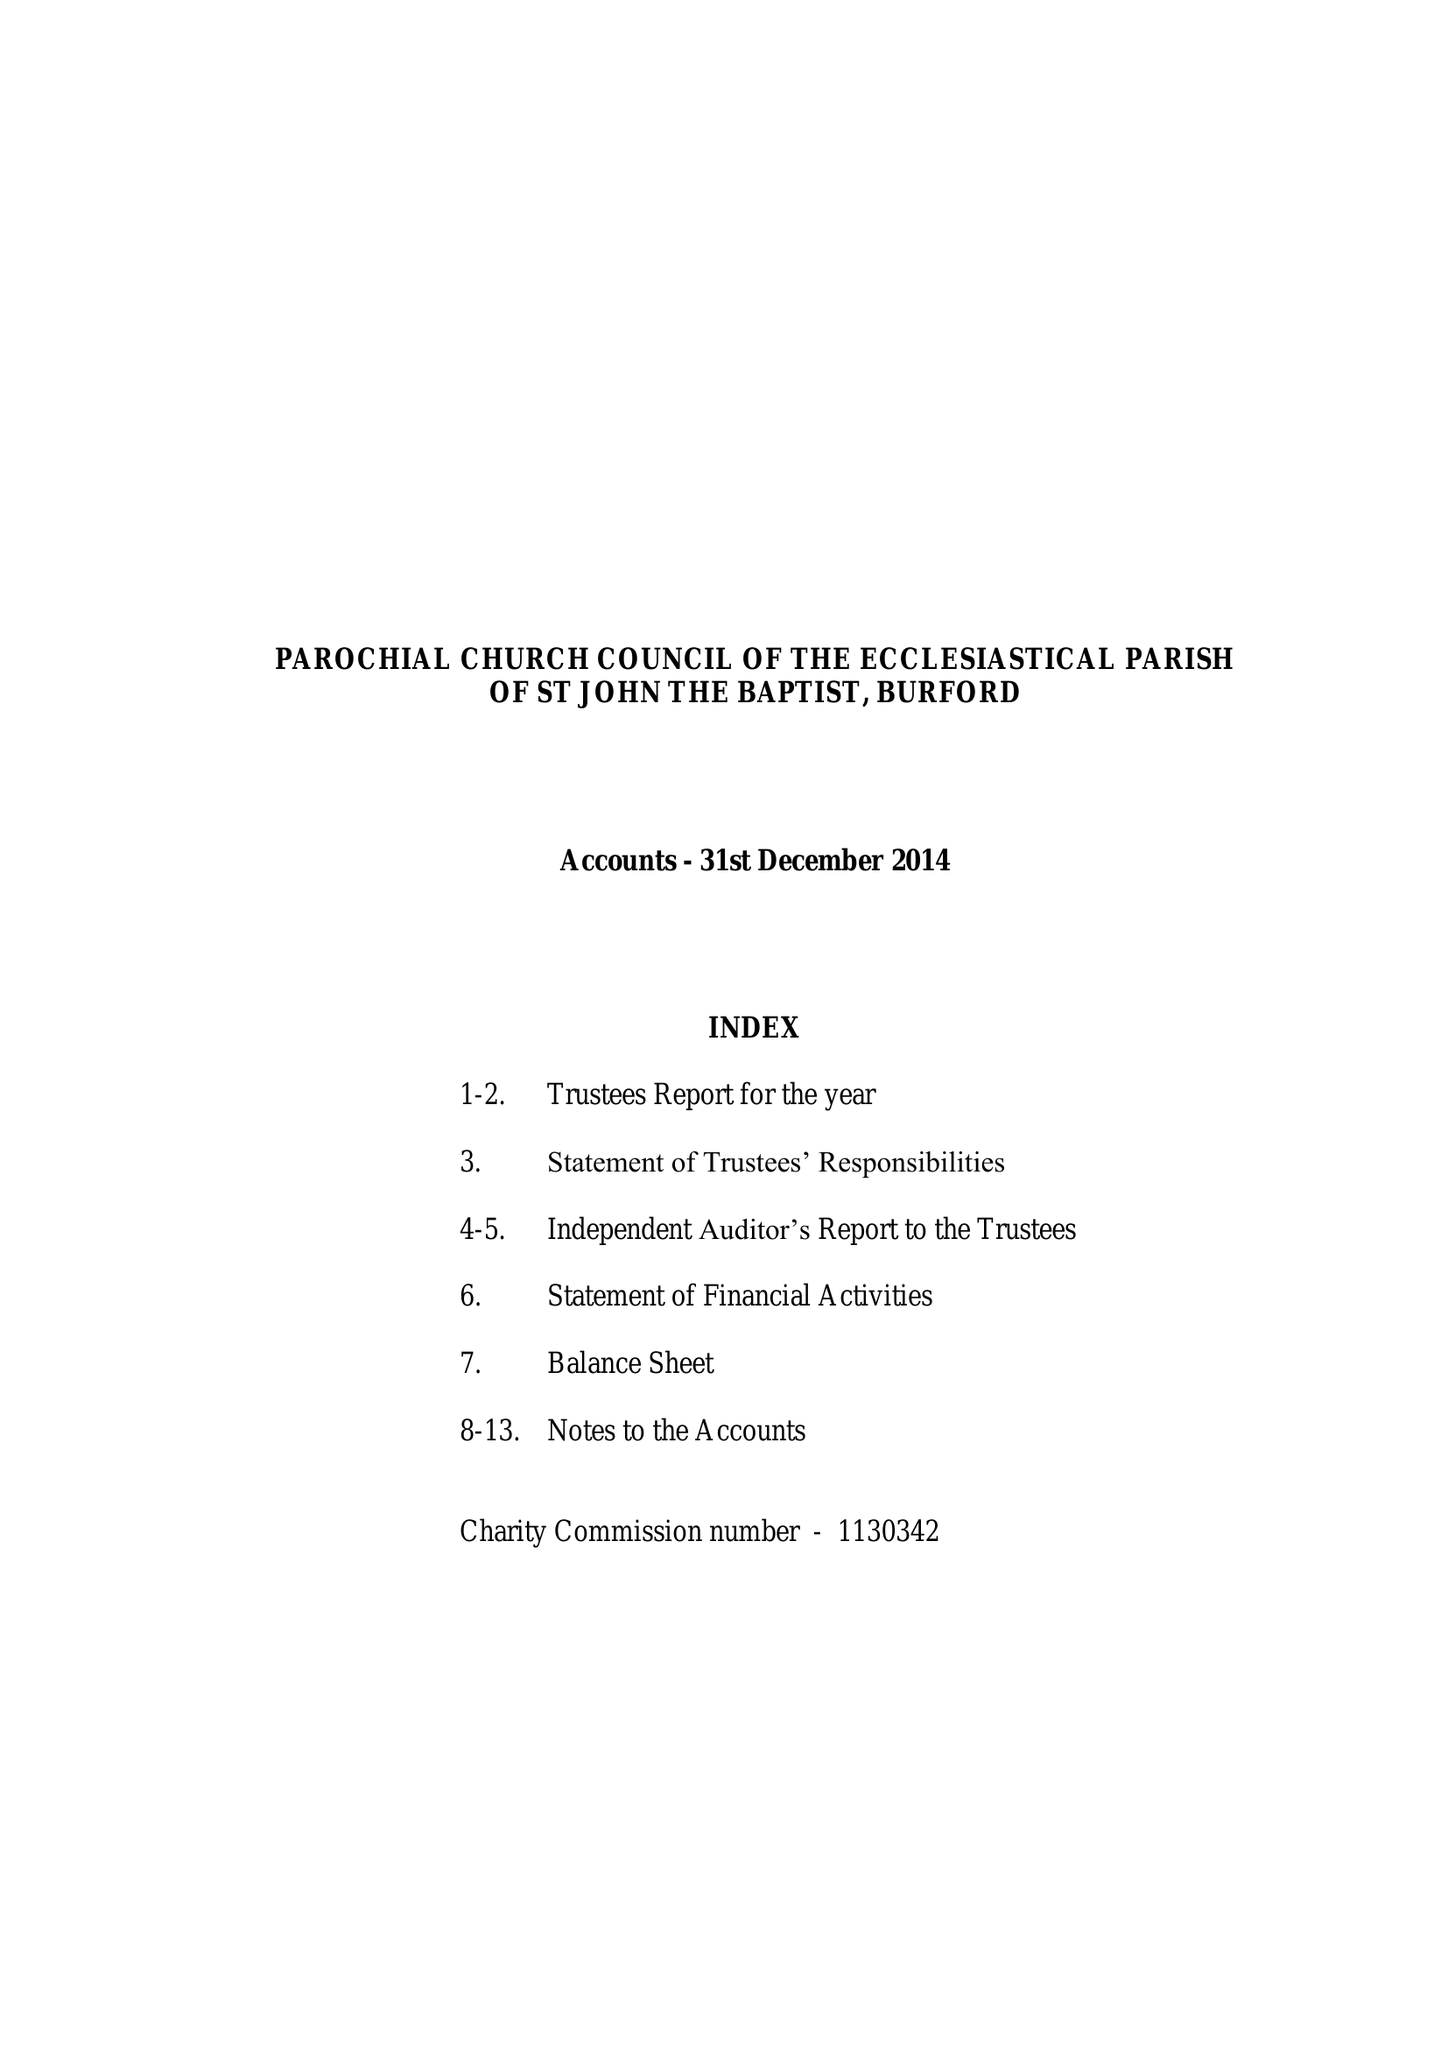What is the value for the address__street_line?
Answer the question using a single word or phrase. CHURCH GREEN 